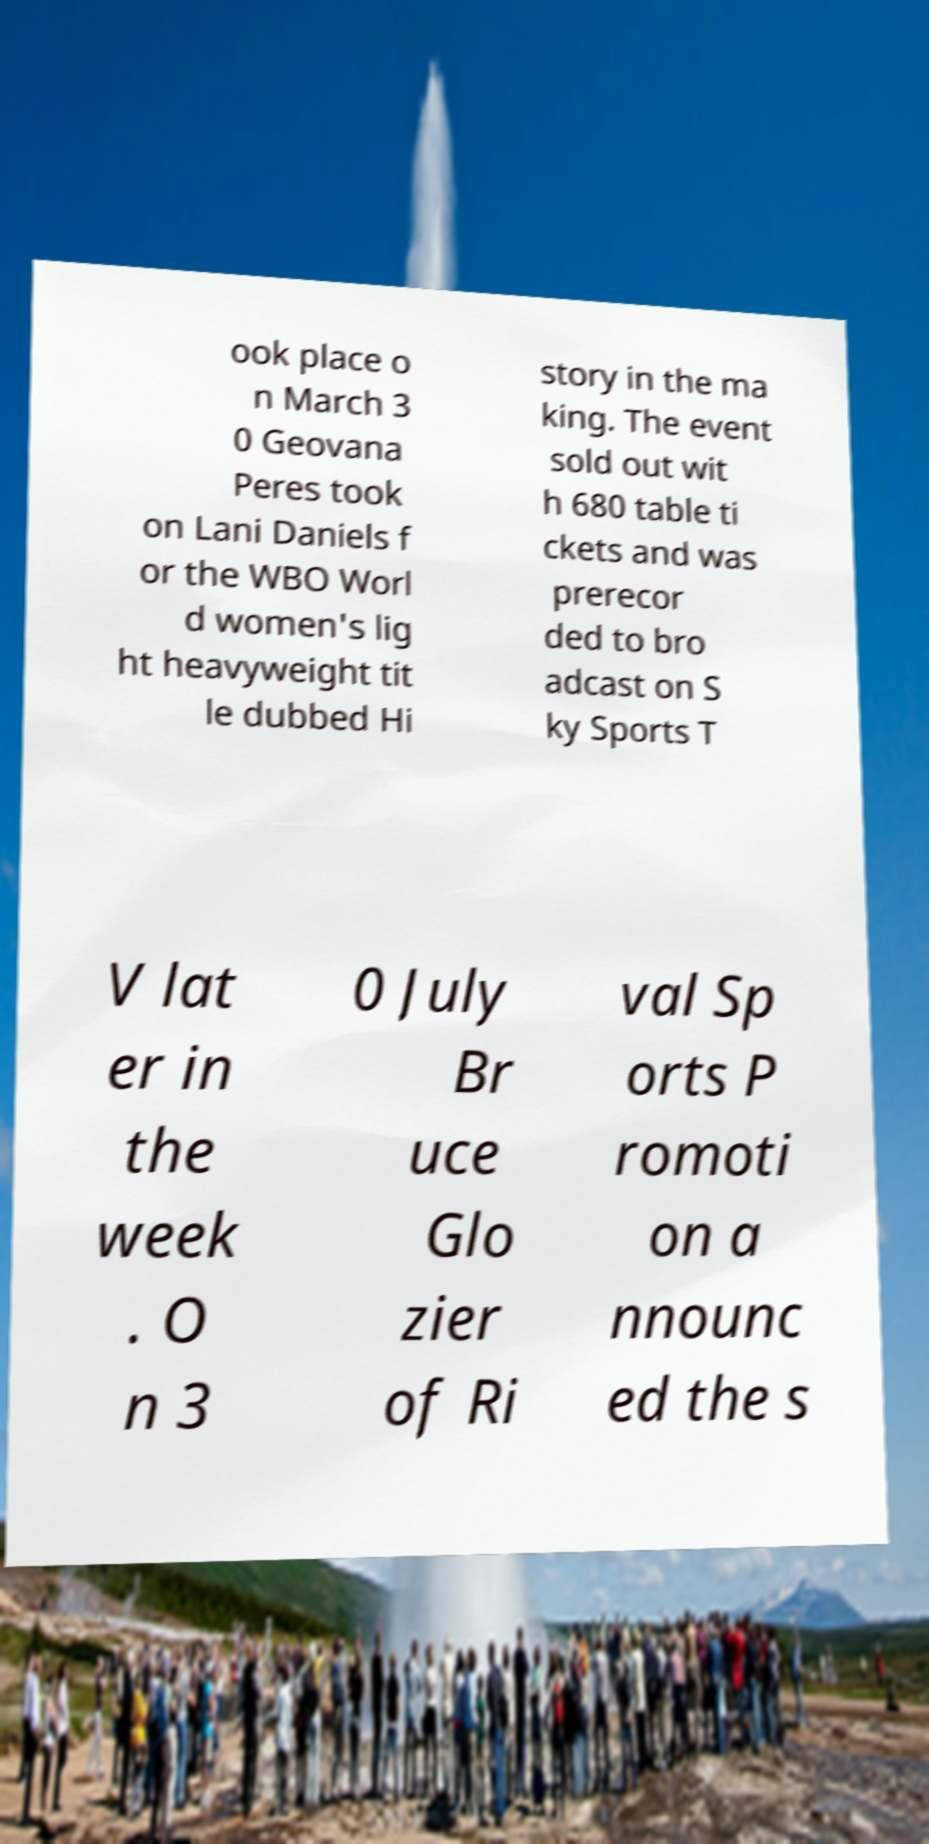Can you accurately transcribe the text from the provided image for me? ook place o n March 3 0 Geovana Peres took on Lani Daniels f or the WBO Worl d women's lig ht heavyweight tit le dubbed Hi story in the ma king. The event sold out wit h 680 table ti ckets and was prerecor ded to bro adcast on S ky Sports T V lat er in the week . O n 3 0 July Br uce Glo zier of Ri val Sp orts P romoti on a nnounc ed the s 